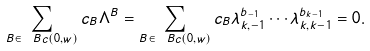<formula> <loc_0><loc_0><loc_500><loc_500>\sum _ { B \in \ B c ( 0 , w ) } c _ { B } \Lambda ^ { B } = \sum _ { B \in \ B c ( 0 , w ) } c _ { B } \lambda _ { k , - 1 } ^ { b _ { - 1 } } \cdots \lambda _ { k , k - 1 } ^ { b _ { k - 1 } } = 0 .</formula> 